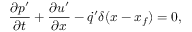Convert formula to latex. <formula><loc_0><loc_0><loc_500><loc_500>\frac { \partial p ^ { \prime } } { \partial t } + \frac { \partial u ^ { \prime } } { \partial x } - \dot { q } ^ { \prime } \delta ( x - x _ { f } ) = 0 ,</formula> 